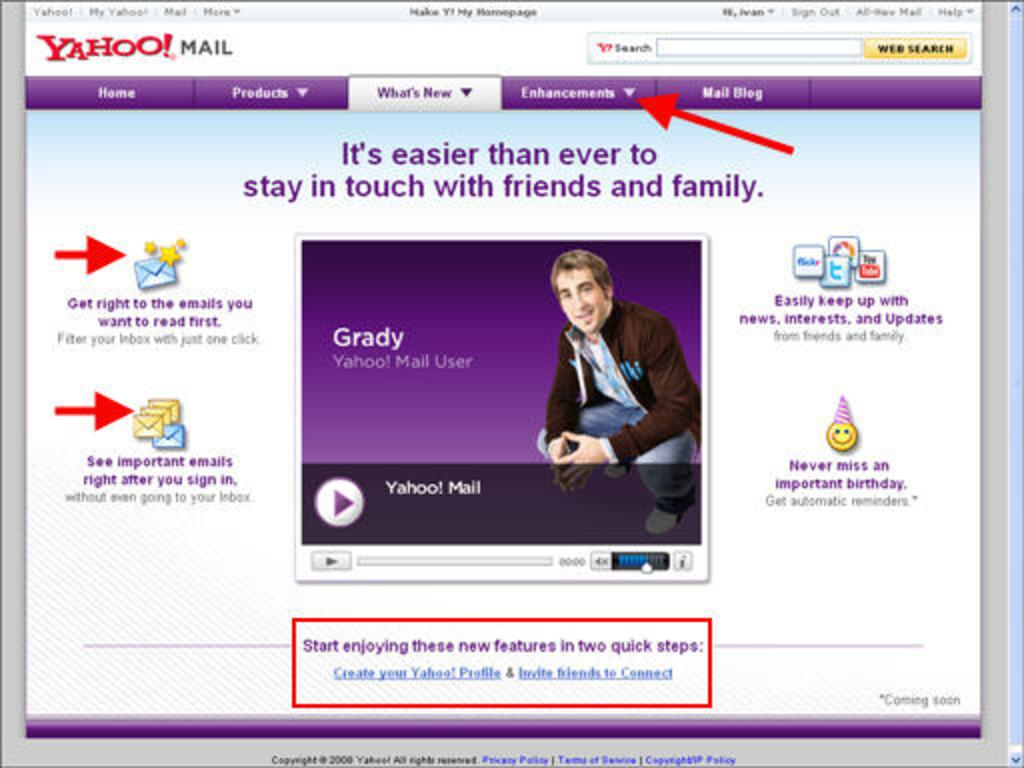What type of content is displayed in the image? The image is a web page. What can be found on the web page? There are words, icons, an image, folders, a search bar, and drop-down boxes on the web page. What type of chicken can be seen on the web page? There is no chicken present on the web page; it is a web page with various elements such as words, icons, an image, folders, a search bar, and drop-down boxes. 